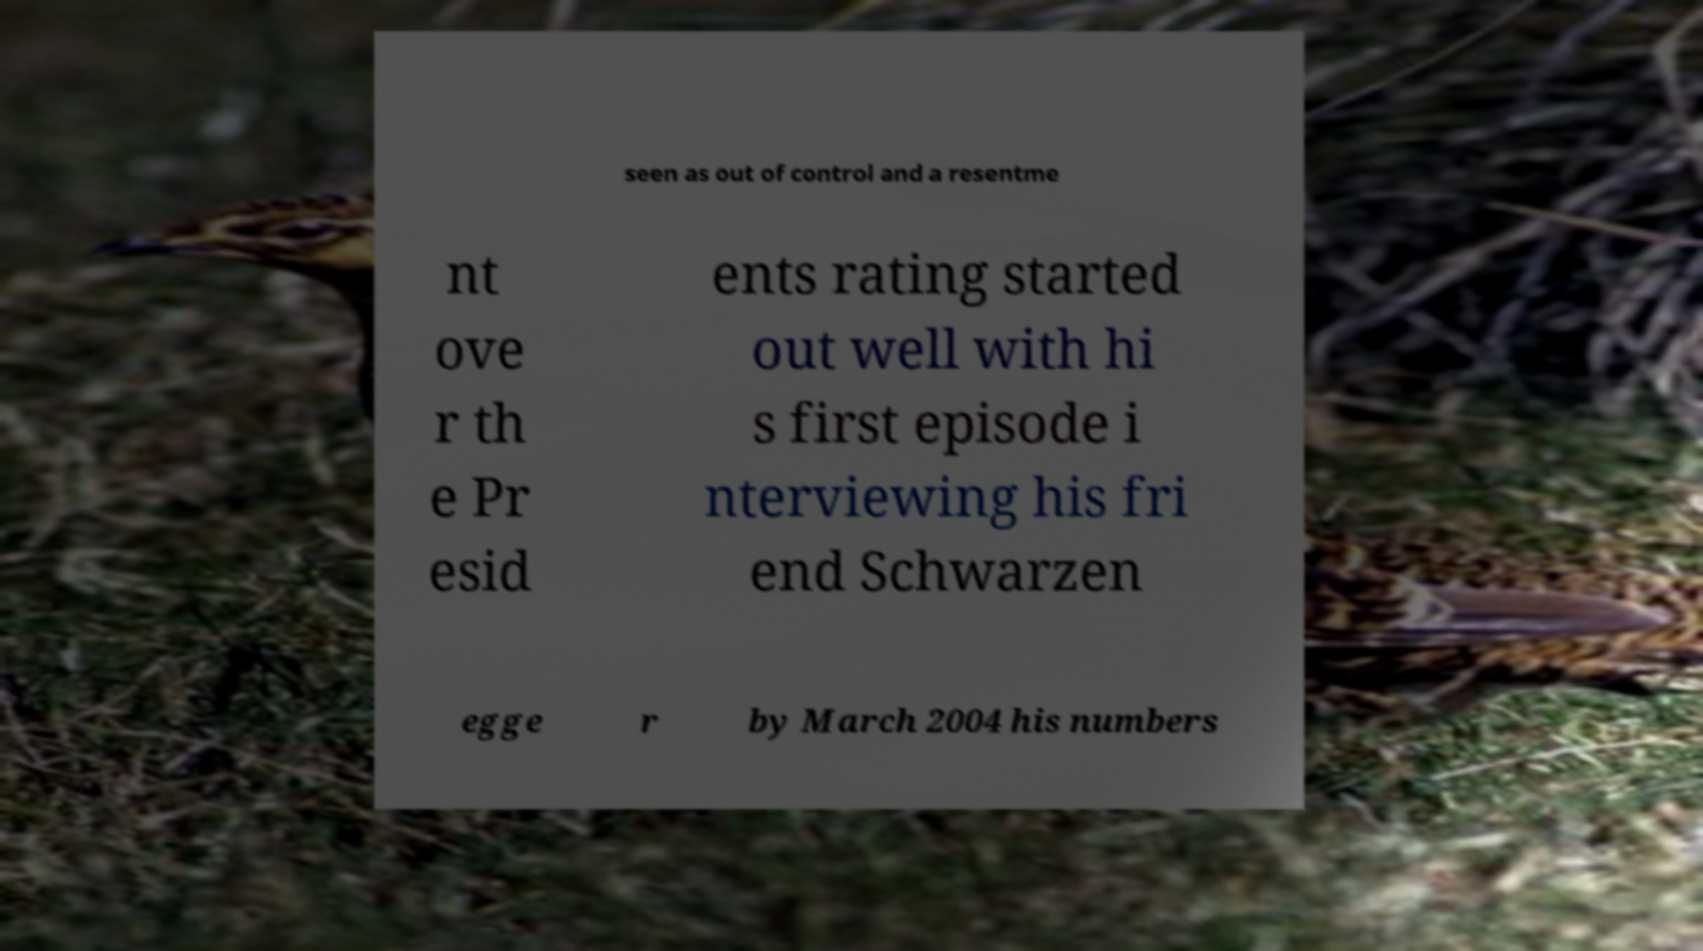There's text embedded in this image that I need extracted. Can you transcribe it verbatim? seen as out of control and a resentme nt ove r th e Pr esid ents rating started out well with hi s first episode i nterviewing his fri end Schwarzen egge r by March 2004 his numbers 